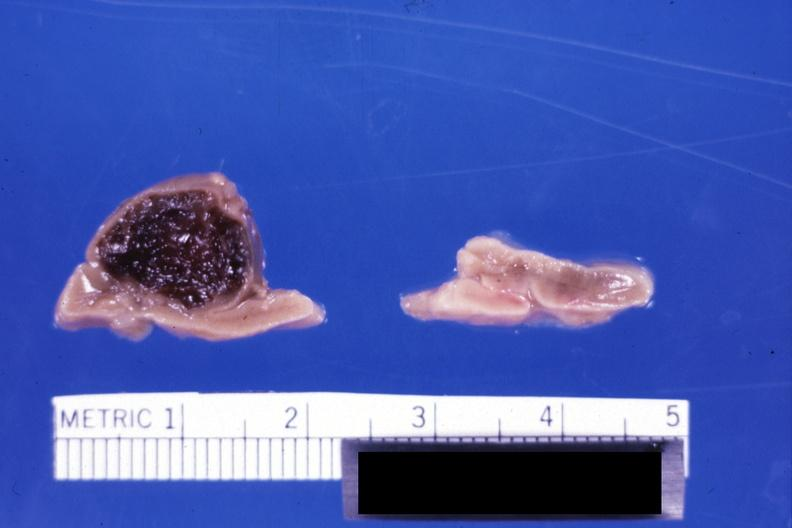s hematoma present?
Answer the question using a single word or phrase. Yes 